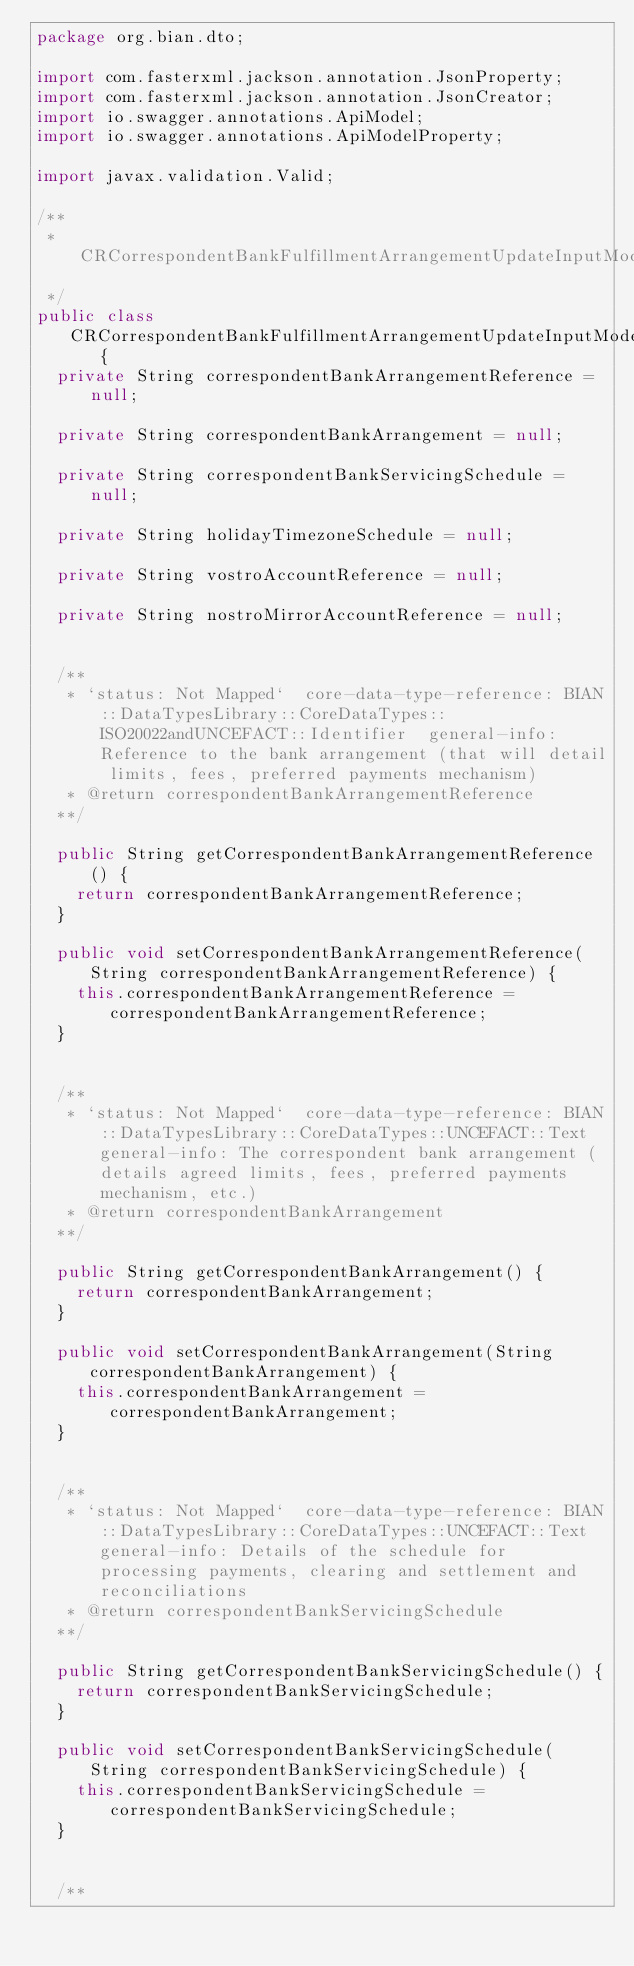<code> <loc_0><loc_0><loc_500><loc_500><_Java_>package org.bian.dto;

import com.fasterxml.jackson.annotation.JsonProperty;
import com.fasterxml.jackson.annotation.JsonCreator;
import io.swagger.annotations.ApiModel;
import io.swagger.annotations.ApiModelProperty;

import javax.validation.Valid;
  
/**
 * CRCorrespondentBankFulfillmentArrangementUpdateInputModelCorrespondentBankFulfillmentArrangementInstanceRecord
 */
public class CRCorrespondentBankFulfillmentArrangementUpdateInputModelCorrespondentBankFulfillmentArrangementInstanceRecord   {
  private String correspondentBankArrangementReference = null;

  private String correspondentBankArrangement = null;

  private String correspondentBankServicingSchedule = null;

  private String holidayTimezoneSchedule = null;

  private String vostroAccountReference = null;

  private String nostroMirrorAccountReference = null;


  /**
   * `status: Not Mapped`  core-data-type-reference: BIAN::DataTypesLibrary::CoreDataTypes::ISO20022andUNCEFACT::Identifier  general-info: Reference to the bank arrangement (that will detail limits, fees, preferred payments mechanism) 
   * @return correspondentBankArrangementReference
  **/

  public String getCorrespondentBankArrangementReference() {
    return correspondentBankArrangementReference;
  }

  public void setCorrespondentBankArrangementReference(String correspondentBankArrangementReference) {
    this.correspondentBankArrangementReference = correspondentBankArrangementReference;
  }


  /**
   * `status: Not Mapped`  core-data-type-reference: BIAN::DataTypesLibrary::CoreDataTypes::UNCEFACT::Text  general-info: The correspondent bank arrangement (details agreed limits, fees, preferred payments mechanism, etc.) 
   * @return correspondentBankArrangement
  **/

  public String getCorrespondentBankArrangement() {
    return correspondentBankArrangement;
  }

  public void setCorrespondentBankArrangement(String correspondentBankArrangement) {
    this.correspondentBankArrangement = correspondentBankArrangement;
  }


  /**
   * `status: Not Mapped`  core-data-type-reference: BIAN::DataTypesLibrary::CoreDataTypes::UNCEFACT::Text  general-info: Details of the schedule for processing payments, clearing and settlement and reconciliations 
   * @return correspondentBankServicingSchedule
  **/

  public String getCorrespondentBankServicingSchedule() {
    return correspondentBankServicingSchedule;
  }

  public void setCorrespondentBankServicingSchedule(String correspondentBankServicingSchedule) {
    this.correspondentBankServicingSchedule = correspondentBankServicingSchedule;
  }


  /**</code> 